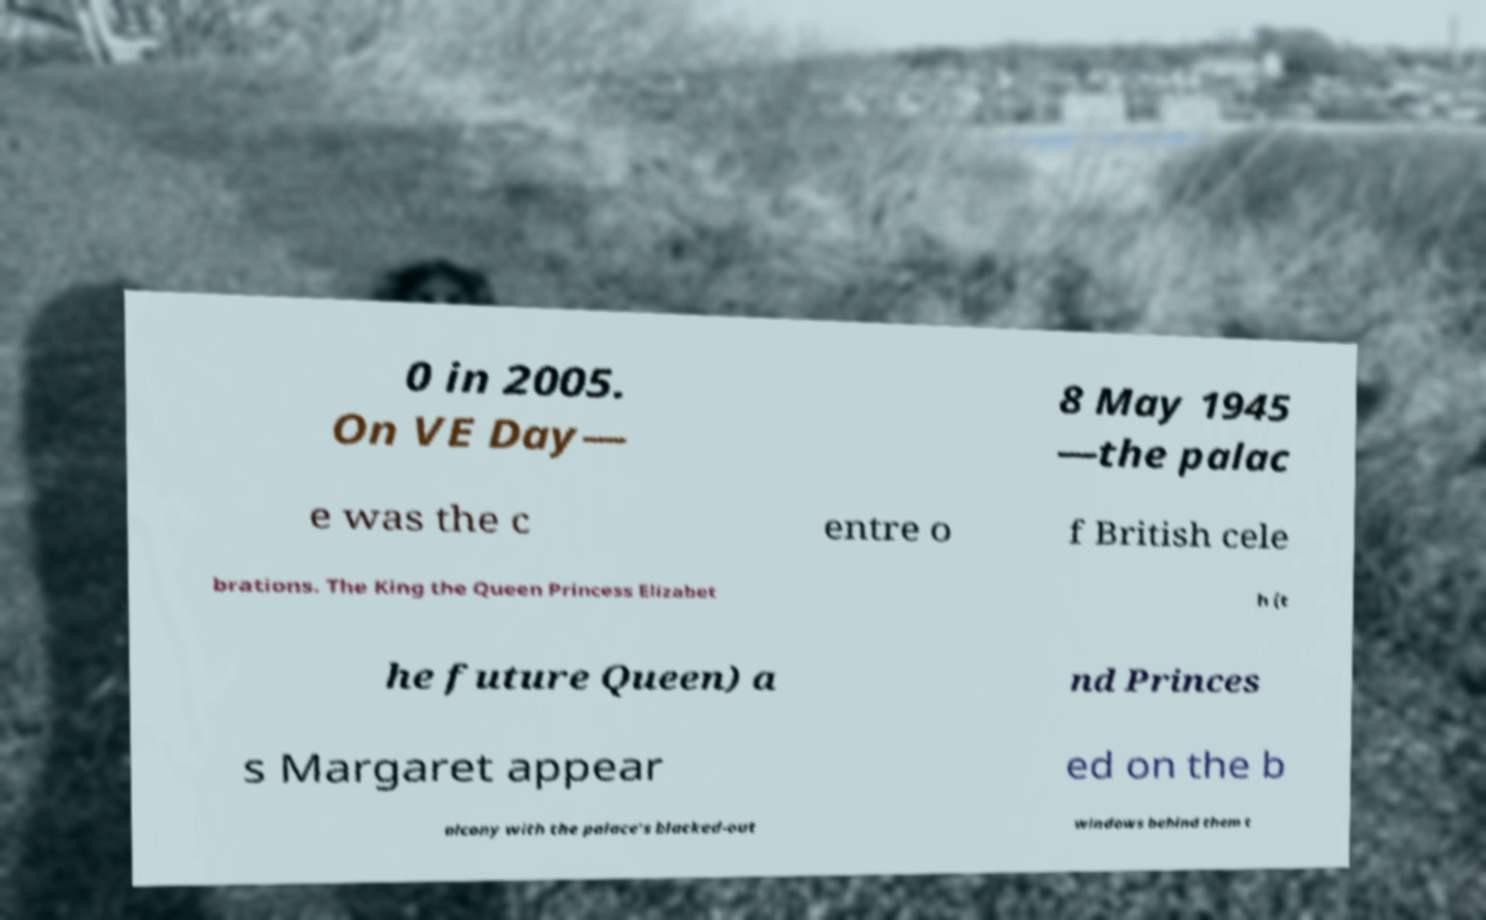For documentation purposes, I need the text within this image transcribed. Could you provide that? 0 in 2005. On VE Day— 8 May 1945 —the palac e was the c entre o f British cele brations. The King the Queen Princess Elizabet h (t he future Queen) a nd Princes s Margaret appear ed on the b alcony with the palace's blacked-out windows behind them t 